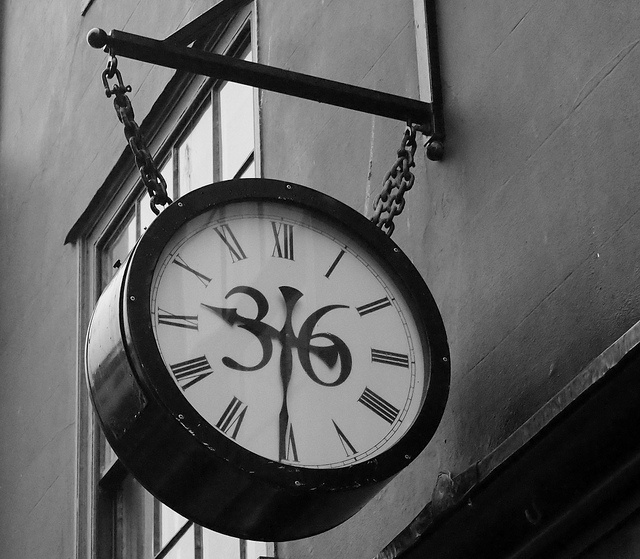Describe the objects in this image and their specific colors. I can see a clock in black, darkgray, gray, and lightgray tones in this image. 